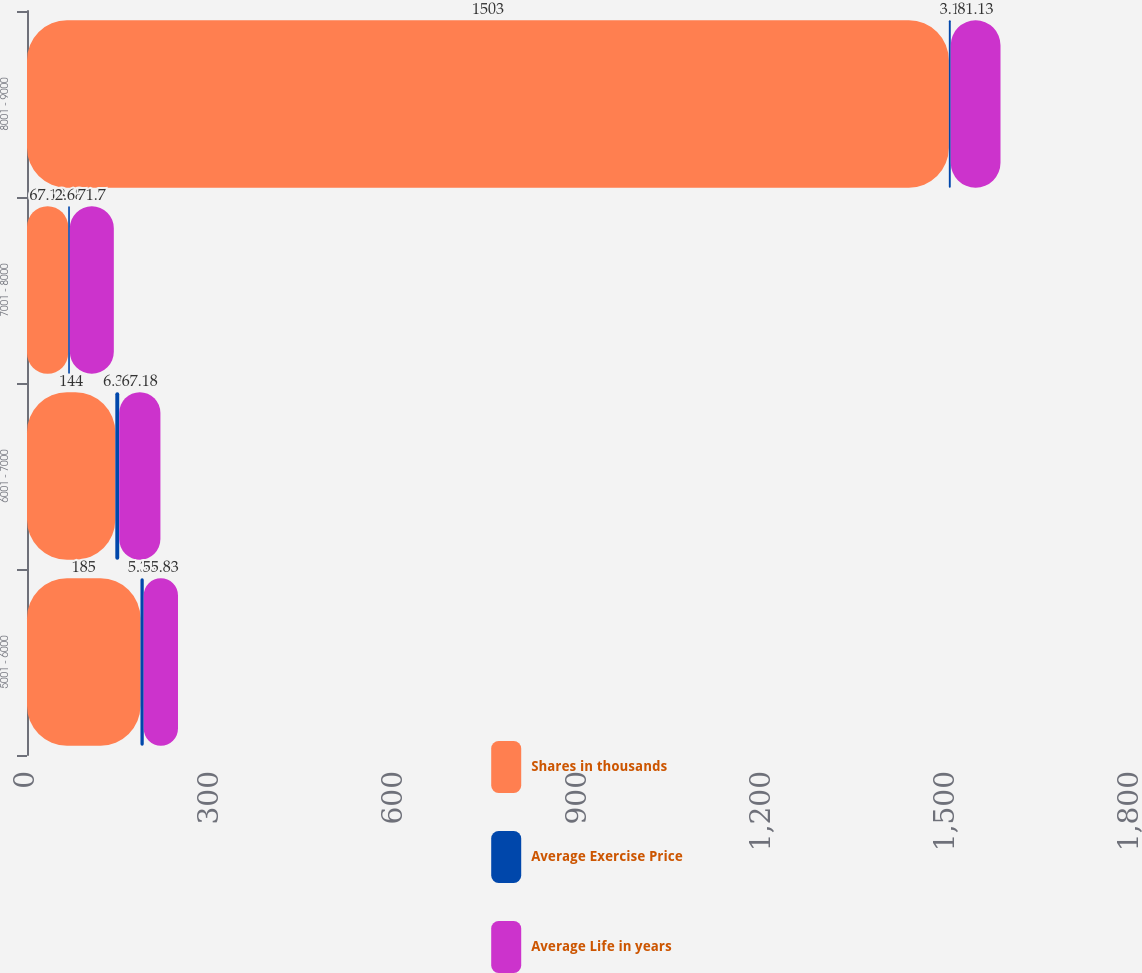Convert chart to OTSL. <chart><loc_0><loc_0><loc_500><loc_500><stacked_bar_chart><ecel><fcel>5001 - 6000<fcel>6001 - 7000<fcel>7001 - 8000<fcel>8001 - 9000<nl><fcel>Shares in thousands<fcel>185<fcel>144<fcel>67.18<fcel>1503<nl><fcel>Average Exercise Price<fcel>5.35<fcel>6.35<fcel>2.68<fcel>3.1<nl><fcel>Average Life in years<fcel>55.83<fcel>67.18<fcel>71.7<fcel>81.13<nl></chart> 